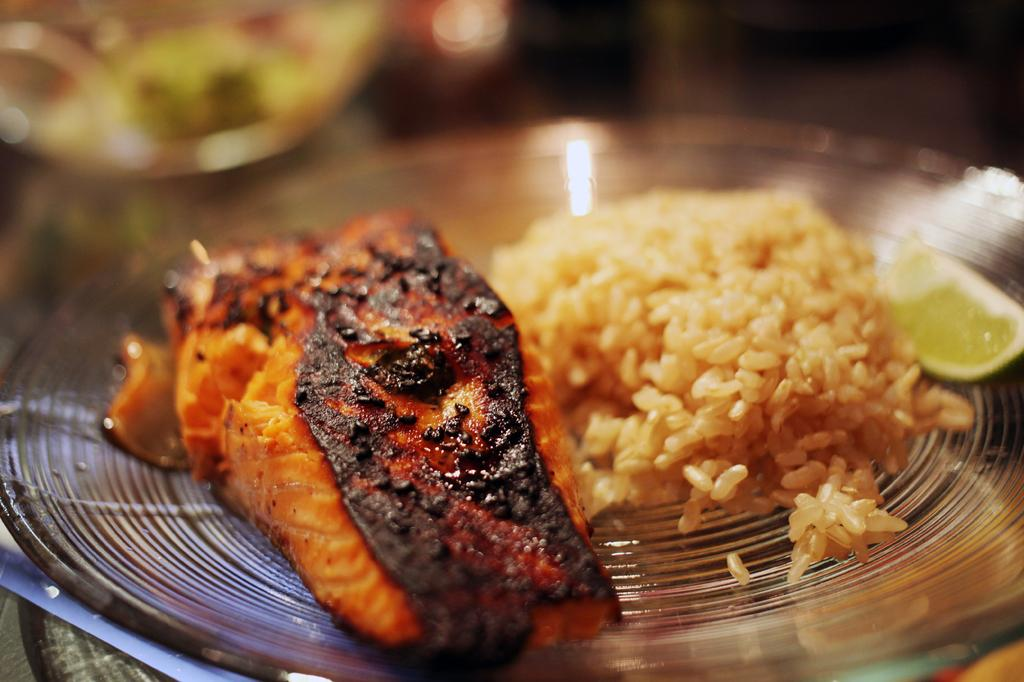What is the main subject of the image? There is a food item on a glass plate in the image. Can you describe the background of the image? The background of the image is blurry. What chance does the food item have of singing a song in the image? The food item does not have the ability to sing a song, as it is an inanimate object. 